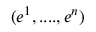<formula> <loc_0><loc_0><loc_500><loc_500>( e ^ { 1 } , \cdots , e ^ { n } )</formula> 